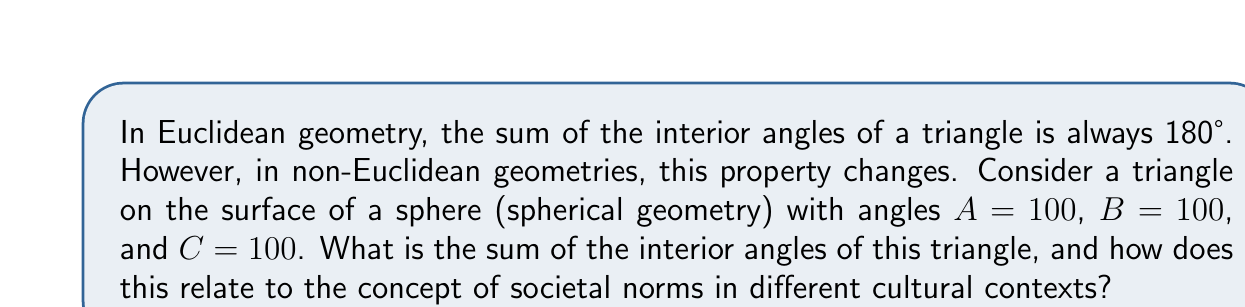Can you solve this math problem? 1. In Euclidean geometry:
   - The sum of interior angles of a triangle is always 180°
   - This represents a "flat" or uniform societal structure

2. In spherical geometry (a type of non-Euclidean geometry):
   - The sum of interior angles of a triangle is always greater than 180°
   - The formula for the sum of angles in a spherical triangle is:
     $$ S = A + B + C - 180° $$
     where S is the spherical excess and A, B, C are the angles of the triangle

3. For the given triangle:
   $$ S = 100° + 100° + 100° - 180° = 300° - 180° = 120° $$

4. The total sum of interior angles:
   $$ \text{Total sum} = A + B + C = 100° + 100° + 100° = 300° $$

5. Sociological interpretation:
   - Euclidean geometry (180° sum) represents societies with rigid, uniform norms
   - Non-Euclidean geometry (>180° sum) represents societies with more flexible, diverse norms
   - The spherical triangle's 300° sum suggests a society with a high degree of cultural diversity and flexibility in social structures

6. The "excess" (120° in this case) can be seen as a metaphor for the additional complexity and richness in diverse societies compared to more homogeneous ones
Answer: 300°; represents societal diversity and flexible norms 